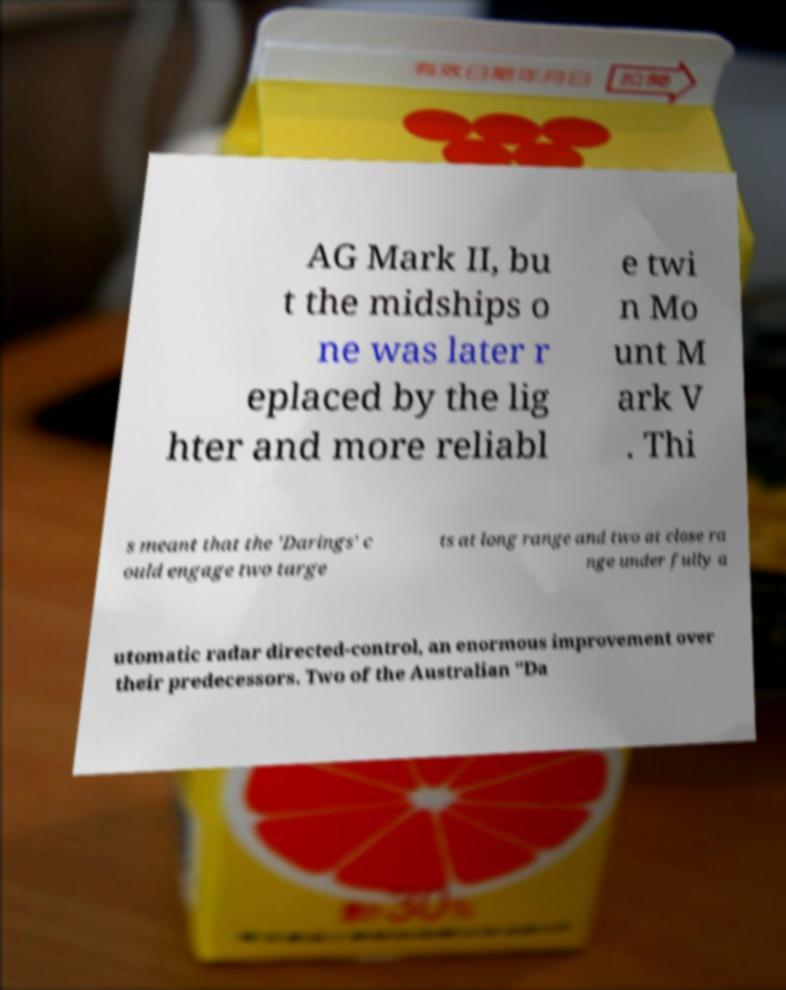What messages or text are displayed in this image? I need them in a readable, typed format. AG Mark II, bu t the midships o ne was later r eplaced by the lig hter and more reliabl e twi n Mo unt M ark V . Thi s meant that the 'Darings' c ould engage two targe ts at long range and two at close ra nge under fully a utomatic radar directed-control, an enormous improvement over their predecessors. Two of the Australian "Da 